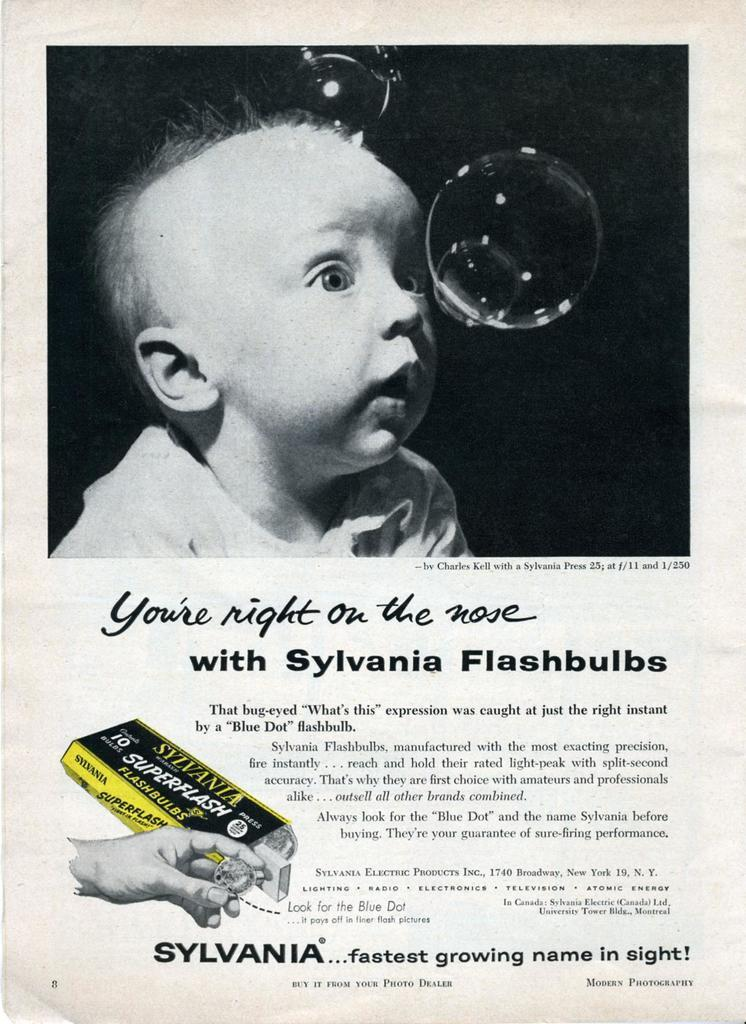What is featured in the image? There is a poster in the image. What can be found on the poster? The poster contains text and images. Can you describe the picture on the poster? The poster has a black and white picture of a baby. What is the person's hand holding in the poster? One person's hand is holding an object in the poster. What color is the paint on the baby's face in the image? There is no paint on the baby's face in the image; it is a black and white picture. What causes the spark in the image? There is no spark present in the image. 